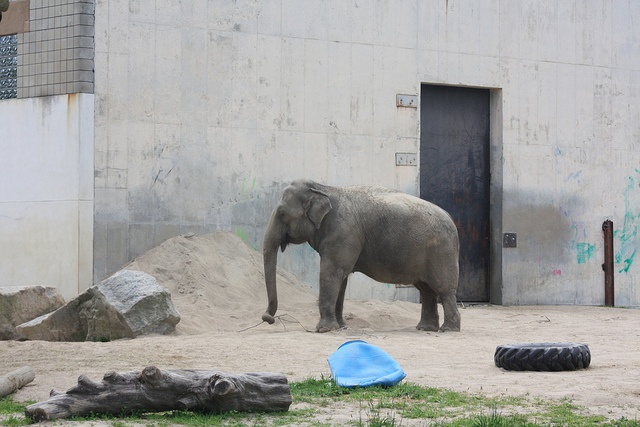Describe the objects in this image and their specific colors. I can see a elephant in gray, black, and darkgray tones in this image. 